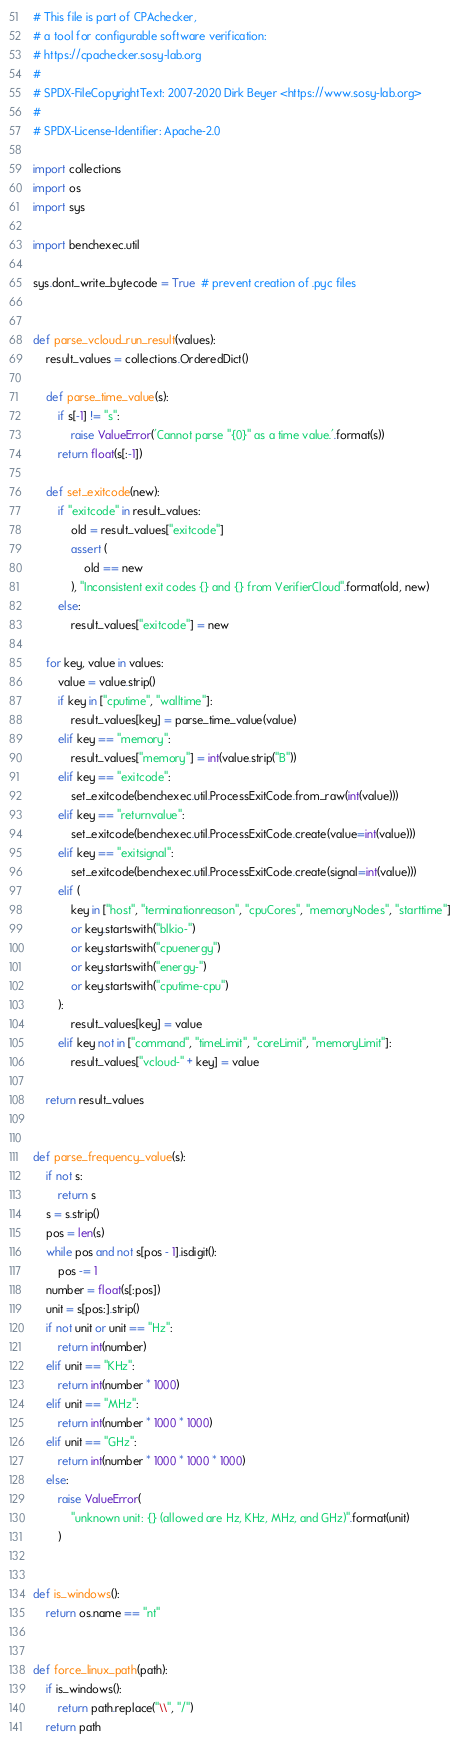Convert code to text. <code><loc_0><loc_0><loc_500><loc_500><_Python_># This file is part of CPAchecker,
# a tool for configurable software verification:
# https://cpachecker.sosy-lab.org
#
# SPDX-FileCopyrightText: 2007-2020 Dirk Beyer <https://www.sosy-lab.org>
#
# SPDX-License-Identifier: Apache-2.0

import collections
import os
import sys

import benchexec.util

sys.dont_write_bytecode = True  # prevent creation of .pyc files


def parse_vcloud_run_result(values):
    result_values = collections.OrderedDict()

    def parse_time_value(s):
        if s[-1] != "s":
            raise ValueError('Cannot parse "{0}" as a time value.'.format(s))
        return float(s[:-1])

    def set_exitcode(new):
        if "exitcode" in result_values:
            old = result_values["exitcode"]
            assert (
                old == new
            ), "Inconsistent exit codes {} and {} from VerifierCloud".format(old, new)
        else:
            result_values["exitcode"] = new

    for key, value in values:
        value = value.strip()
        if key in ["cputime", "walltime"]:
            result_values[key] = parse_time_value(value)
        elif key == "memory":
            result_values["memory"] = int(value.strip("B"))
        elif key == "exitcode":
            set_exitcode(benchexec.util.ProcessExitCode.from_raw(int(value)))
        elif key == "returnvalue":
            set_exitcode(benchexec.util.ProcessExitCode.create(value=int(value)))
        elif key == "exitsignal":
            set_exitcode(benchexec.util.ProcessExitCode.create(signal=int(value)))
        elif (
            key in ["host", "terminationreason", "cpuCores", "memoryNodes", "starttime"]
            or key.startswith("blkio-")
            or key.startswith("cpuenergy")
            or key.startswith("energy-")
            or key.startswith("cputime-cpu")
        ):
            result_values[key] = value
        elif key not in ["command", "timeLimit", "coreLimit", "memoryLimit"]:
            result_values["vcloud-" + key] = value

    return result_values


def parse_frequency_value(s):
    if not s:
        return s
    s = s.strip()
    pos = len(s)
    while pos and not s[pos - 1].isdigit():
        pos -= 1
    number = float(s[:pos])
    unit = s[pos:].strip()
    if not unit or unit == "Hz":
        return int(number)
    elif unit == "KHz":
        return int(number * 1000)
    elif unit == "MHz":
        return int(number * 1000 * 1000)
    elif unit == "GHz":
        return int(number * 1000 * 1000 * 1000)
    else:
        raise ValueError(
            "unknown unit: {} (allowed are Hz, KHz, MHz, and GHz)".format(unit)
        )


def is_windows():
    return os.name == "nt"


def force_linux_path(path):
    if is_windows():
        return path.replace("\\", "/")
    return path
</code> 